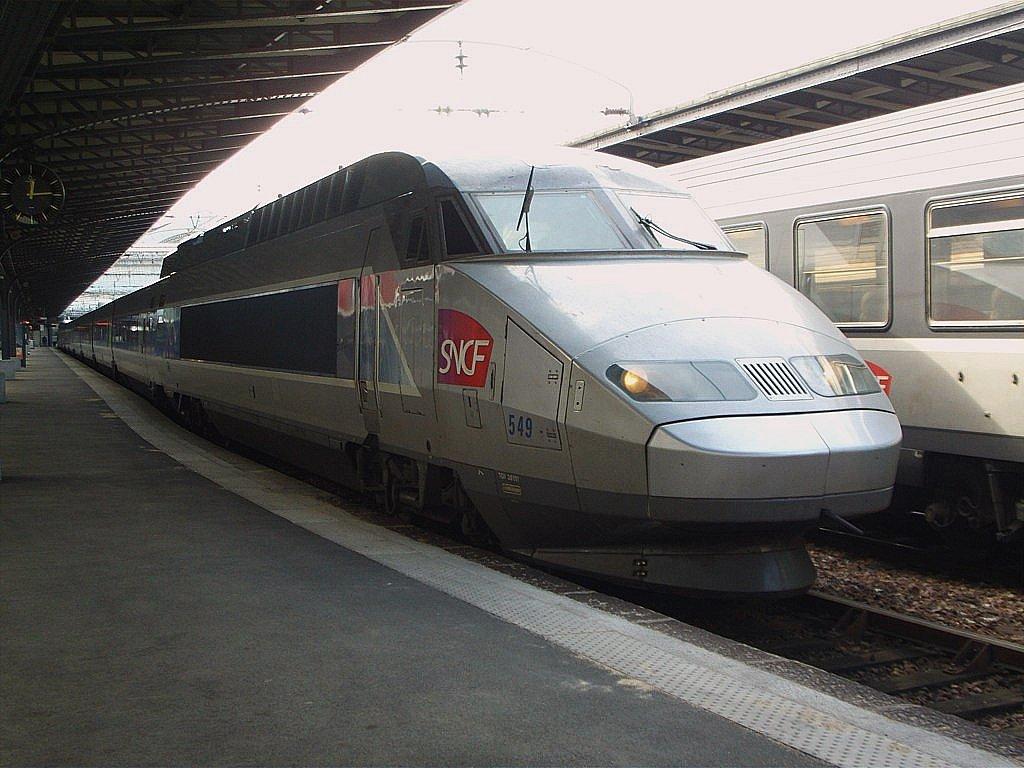What letters are on the train?
Your answer should be very brief. Sncf. What numbers are in blue on the train?
Give a very brief answer. 549. 